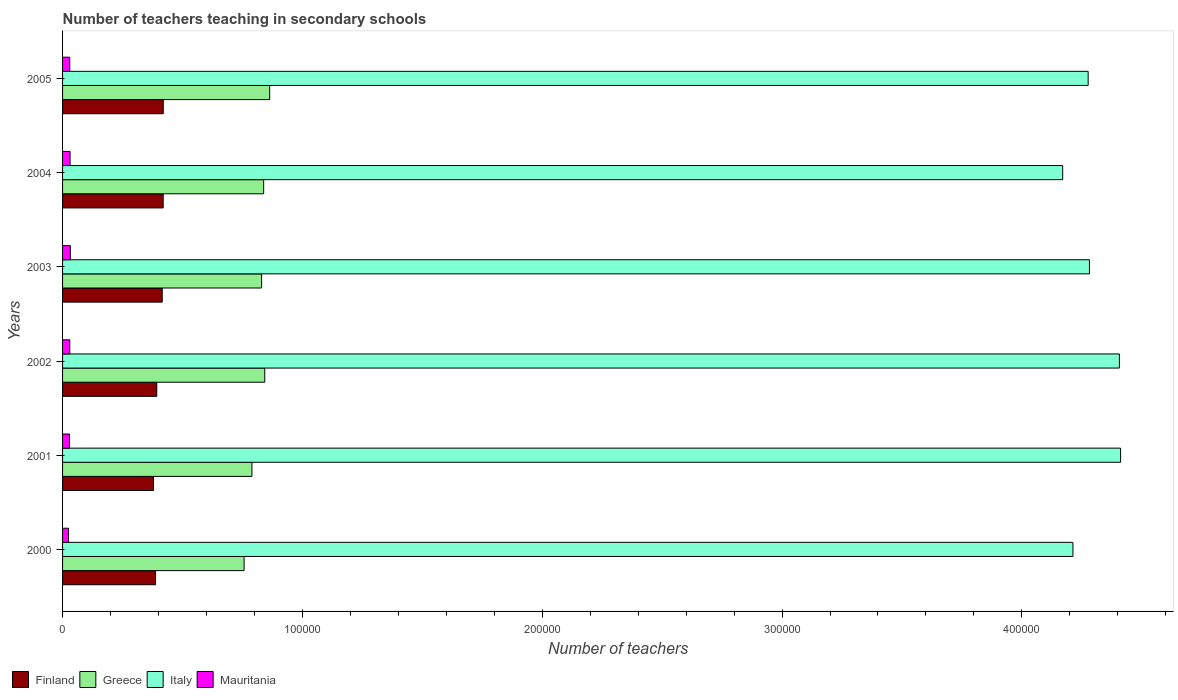How many different coloured bars are there?
Ensure brevity in your answer.  4. How many groups of bars are there?
Offer a very short reply. 6. Are the number of bars on each tick of the Y-axis equal?
Provide a short and direct response. Yes. How many bars are there on the 3rd tick from the bottom?
Make the answer very short. 4. What is the label of the 6th group of bars from the top?
Make the answer very short. 2000. What is the number of teachers teaching in secondary schools in Italy in 2001?
Give a very brief answer. 4.41e+05. Across all years, what is the maximum number of teachers teaching in secondary schools in Mauritania?
Provide a short and direct response. 3237. Across all years, what is the minimum number of teachers teaching in secondary schools in Finland?
Provide a succinct answer. 3.79e+04. In which year was the number of teachers teaching in secondary schools in Italy minimum?
Offer a very short reply. 2004. What is the total number of teachers teaching in secondary schools in Finland in the graph?
Your answer should be compact. 2.41e+05. What is the difference between the number of teachers teaching in secondary schools in Greece in 2002 and that in 2004?
Your answer should be very brief. 457. What is the difference between the number of teachers teaching in secondary schools in Mauritania in 2004 and the number of teachers teaching in secondary schools in Italy in 2002?
Give a very brief answer. -4.38e+05. What is the average number of teachers teaching in secondary schools in Italy per year?
Provide a succinct answer. 4.29e+05. In the year 2004, what is the difference between the number of teachers teaching in secondary schools in Mauritania and number of teachers teaching in secondary schools in Italy?
Make the answer very short. -4.14e+05. What is the ratio of the number of teachers teaching in secondary schools in Greece in 2000 to that in 2005?
Ensure brevity in your answer.  0.88. Is the difference between the number of teachers teaching in secondary schools in Mauritania in 2000 and 2003 greater than the difference between the number of teachers teaching in secondary schools in Italy in 2000 and 2003?
Offer a terse response. Yes. What is the difference between the highest and the second highest number of teachers teaching in secondary schools in Italy?
Keep it short and to the point. 501. What is the difference between the highest and the lowest number of teachers teaching in secondary schools in Finland?
Your answer should be very brief. 4057. Is the sum of the number of teachers teaching in secondary schools in Finland in 2004 and 2005 greater than the maximum number of teachers teaching in secondary schools in Mauritania across all years?
Your answer should be very brief. Yes. What does the 4th bar from the top in 2004 represents?
Provide a succinct answer. Finland. What does the 4th bar from the bottom in 2002 represents?
Offer a very short reply. Mauritania. How many bars are there?
Your response must be concise. 24. Are all the bars in the graph horizontal?
Make the answer very short. Yes. What is the difference between two consecutive major ticks on the X-axis?
Your response must be concise. 1.00e+05. Are the values on the major ticks of X-axis written in scientific E-notation?
Keep it short and to the point. No. Does the graph contain any zero values?
Keep it short and to the point. No. Where does the legend appear in the graph?
Ensure brevity in your answer.  Bottom left. How many legend labels are there?
Offer a terse response. 4. How are the legend labels stacked?
Give a very brief answer. Horizontal. What is the title of the graph?
Your response must be concise. Number of teachers teaching in secondary schools. What is the label or title of the X-axis?
Give a very brief answer. Number of teachers. What is the label or title of the Y-axis?
Provide a succinct answer. Years. What is the Number of teachers of Finland in 2000?
Offer a very short reply. 3.88e+04. What is the Number of teachers of Greece in 2000?
Provide a short and direct response. 7.57e+04. What is the Number of teachers of Italy in 2000?
Provide a succinct answer. 4.21e+05. What is the Number of teachers in Mauritania in 2000?
Offer a very short reply. 2492. What is the Number of teachers in Finland in 2001?
Make the answer very short. 3.79e+04. What is the Number of teachers in Greece in 2001?
Provide a succinct answer. 7.90e+04. What is the Number of teachers in Italy in 2001?
Make the answer very short. 4.41e+05. What is the Number of teachers in Mauritania in 2001?
Your answer should be very brief. 2911. What is the Number of teachers in Finland in 2002?
Offer a terse response. 3.93e+04. What is the Number of teachers of Greece in 2002?
Provide a succinct answer. 8.43e+04. What is the Number of teachers in Italy in 2002?
Ensure brevity in your answer.  4.41e+05. What is the Number of teachers of Mauritania in 2002?
Keep it short and to the point. 3000. What is the Number of teachers in Finland in 2003?
Your answer should be very brief. 4.16e+04. What is the Number of teachers in Greece in 2003?
Keep it short and to the point. 8.30e+04. What is the Number of teachers of Italy in 2003?
Keep it short and to the point. 4.28e+05. What is the Number of teachers in Mauritania in 2003?
Keep it short and to the point. 3237. What is the Number of teachers in Finland in 2004?
Provide a short and direct response. 4.20e+04. What is the Number of teachers in Greece in 2004?
Provide a short and direct response. 8.38e+04. What is the Number of teachers in Italy in 2004?
Provide a short and direct response. 4.17e+05. What is the Number of teachers in Mauritania in 2004?
Offer a terse response. 3126. What is the Number of teachers in Finland in 2005?
Keep it short and to the point. 4.20e+04. What is the Number of teachers in Greece in 2005?
Offer a terse response. 8.64e+04. What is the Number of teachers in Italy in 2005?
Make the answer very short. 4.28e+05. What is the Number of teachers of Mauritania in 2005?
Offer a very short reply. 2995. Across all years, what is the maximum Number of teachers of Finland?
Give a very brief answer. 4.20e+04. Across all years, what is the maximum Number of teachers of Greece?
Your response must be concise. 8.64e+04. Across all years, what is the maximum Number of teachers in Italy?
Your answer should be very brief. 4.41e+05. Across all years, what is the maximum Number of teachers of Mauritania?
Give a very brief answer. 3237. Across all years, what is the minimum Number of teachers in Finland?
Offer a terse response. 3.79e+04. Across all years, what is the minimum Number of teachers of Greece?
Give a very brief answer. 7.57e+04. Across all years, what is the minimum Number of teachers in Italy?
Ensure brevity in your answer.  4.17e+05. Across all years, what is the minimum Number of teachers in Mauritania?
Provide a short and direct response. 2492. What is the total Number of teachers of Finland in the graph?
Make the answer very short. 2.41e+05. What is the total Number of teachers of Greece in the graph?
Your answer should be very brief. 4.92e+05. What is the total Number of teachers in Italy in the graph?
Ensure brevity in your answer.  2.58e+06. What is the total Number of teachers of Mauritania in the graph?
Your answer should be compact. 1.78e+04. What is the difference between the Number of teachers of Finland in 2000 and that in 2001?
Your answer should be compact. 851. What is the difference between the Number of teachers of Greece in 2000 and that in 2001?
Your answer should be very brief. -3274. What is the difference between the Number of teachers of Italy in 2000 and that in 2001?
Keep it short and to the point. -1.99e+04. What is the difference between the Number of teachers in Mauritania in 2000 and that in 2001?
Provide a succinct answer. -419. What is the difference between the Number of teachers of Finland in 2000 and that in 2002?
Ensure brevity in your answer.  -500. What is the difference between the Number of teachers of Greece in 2000 and that in 2002?
Ensure brevity in your answer.  -8616. What is the difference between the Number of teachers of Italy in 2000 and that in 2002?
Provide a succinct answer. -1.94e+04. What is the difference between the Number of teachers in Mauritania in 2000 and that in 2002?
Provide a short and direct response. -508. What is the difference between the Number of teachers of Finland in 2000 and that in 2003?
Your answer should be compact. -2779. What is the difference between the Number of teachers of Greece in 2000 and that in 2003?
Ensure brevity in your answer.  -7315. What is the difference between the Number of teachers of Italy in 2000 and that in 2003?
Ensure brevity in your answer.  -6880. What is the difference between the Number of teachers of Mauritania in 2000 and that in 2003?
Keep it short and to the point. -745. What is the difference between the Number of teachers of Finland in 2000 and that in 2004?
Make the answer very short. -3177. What is the difference between the Number of teachers in Greece in 2000 and that in 2004?
Keep it short and to the point. -8159. What is the difference between the Number of teachers of Italy in 2000 and that in 2004?
Make the answer very short. 4274. What is the difference between the Number of teachers in Mauritania in 2000 and that in 2004?
Keep it short and to the point. -634. What is the difference between the Number of teachers in Finland in 2000 and that in 2005?
Give a very brief answer. -3206. What is the difference between the Number of teachers in Greece in 2000 and that in 2005?
Provide a succinct answer. -1.07e+04. What is the difference between the Number of teachers in Italy in 2000 and that in 2005?
Ensure brevity in your answer.  -6349. What is the difference between the Number of teachers in Mauritania in 2000 and that in 2005?
Keep it short and to the point. -503. What is the difference between the Number of teachers of Finland in 2001 and that in 2002?
Offer a very short reply. -1351. What is the difference between the Number of teachers in Greece in 2001 and that in 2002?
Give a very brief answer. -5342. What is the difference between the Number of teachers in Italy in 2001 and that in 2002?
Provide a short and direct response. 501. What is the difference between the Number of teachers of Mauritania in 2001 and that in 2002?
Provide a succinct answer. -89. What is the difference between the Number of teachers of Finland in 2001 and that in 2003?
Ensure brevity in your answer.  -3630. What is the difference between the Number of teachers in Greece in 2001 and that in 2003?
Offer a very short reply. -4041. What is the difference between the Number of teachers in Italy in 2001 and that in 2003?
Your response must be concise. 1.30e+04. What is the difference between the Number of teachers of Mauritania in 2001 and that in 2003?
Your response must be concise. -326. What is the difference between the Number of teachers of Finland in 2001 and that in 2004?
Give a very brief answer. -4028. What is the difference between the Number of teachers in Greece in 2001 and that in 2004?
Keep it short and to the point. -4885. What is the difference between the Number of teachers in Italy in 2001 and that in 2004?
Provide a succinct answer. 2.41e+04. What is the difference between the Number of teachers in Mauritania in 2001 and that in 2004?
Keep it short and to the point. -215. What is the difference between the Number of teachers of Finland in 2001 and that in 2005?
Your answer should be very brief. -4057. What is the difference between the Number of teachers in Greece in 2001 and that in 2005?
Your answer should be compact. -7402. What is the difference between the Number of teachers in Italy in 2001 and that in 2005?
Keep it short and to the point. 1.35e+04. What is the difference between the Number of teachers in Mauritania in 2001 and that in 2005?
Provide a short and direct response. -84. What is the difference between the Number of teachers in Finland in 2002 and that in 2003?
Offer a very short reply. -2279. What is the difference between the Number of teachers in Greece in 2002 and that in 2003?
Make the answer very short. 1301. What is the difference between the Number of teachers in Italy in 2002 and that in 2003?
Your answer should be very brief. 1.25e+04. What is the difference between the Number of teachers in Mauritania in 2002 and that in 2003?
Make the answer very short. -237. What is the difference between the Number of teachers in Finland in 2002 and that in 2004?
Keep it short and to the point. -2677. What is the difference between the Number of teachers in Greece in 2002 and that in 2004?
Your answer should be very brief. 457. What is the difference between the Number of teachers of Italy in 2002 and that in 2004?
Give a very brief answer. 2.36e+04. What is the difference between the Number of teachers in Mauritania in 2002 and that in 2004?
Give a very brief answer. -126. What is the difference between the Number of teachers of Finland in 2002 and that in 2005?
Your response must be concise. -2706. What is the difference between the Number of teachers of Greece in 2002 and that in 2005?
Keep it short and to the point. -2060. What is the difference between the Number of teachers in Italy in 2002 and that in 2005?
Make the answer very short. 1.30e+04. What is the difference between the Number of teachers of Mauritania in 2002 and that in 2005?
Your answer should be very brief. 5. What is the difference between the Number of teachers of Finland in 2003 and that in 2004?
Give a very brief answer. -398. What is the difference between the Number of teachers of Greece in 2003 and that in 2004?
Ensure brevity in your answer.  -844. What is the difference between the Number of teachers in Italy in 2003 and that in 2004?
Your answer should be very brief. 1.12e+04. What is the difference between the Number of teachers of Mauritania in 2003 and that in 2004?
Give a very brief answer. 111. What is the difference between the Number of teachers of Finland in 2003 and that in 2005?
Your answer should be compact. -427. What is the difference between the Number of teachers in Greece in 2003 and that in 2005?
Your answer should be compact. -3361. What is the difference between the Number of teachers in Italy in 2003 and that in 2005?
Ensure brevity in your answer.  531. What is the difference between the Number of teachers of Mauritania in 2003 and that in 2005?
Provide a short and direct response. 242. What is the difference between the Number of teachers of Finland in 2004 and that in 2005?
Give a very brief answer. -29. What is the difference between the Number of teachers in Greece in 2004 and that in 2005?
Make the answer very short. -2517. What is the difference between the Number of teachers of Italy in 2004 and that in 2005?
Keep it short and to the point. -1.06e+04. What is the difference between the Number of teachers of Mauritania in 2004 and that in 2005?
Provide a short and direct response. 131. What is the difference between the Number of teachers in Finland in 2000 and the Number of teachers in Greece in 2001?
Your answer should be very brief. -4.02e+04. What is the difference between the Number of teachers of Finland in 2000 and the Number of teachers of Italy in 2001?
Provide a short and direct response. -4.02e+05. What is the difference between the Number of teachers in Finland in 2000 and the Number of teachers in Mauritania in 2001?
Provide a short and direct response. 3.59e+04. What is the difference between the Number of teachers in Greece in 2000 and the Number of teachers in Italy in 2001?
Provide a succinct answer. -3.65e+05. What is the difference between the Number of teachers of Greece in 2000 and the Number of teachers of Mauritania in 2001?
Keep it short and to the point. 7.28e+04. What is the difference between the Number of teachers of Italy in 2000 and the Number of teachers of Mauritania in 2001?
Offer a terse response. 4.18e+05. What is the difference between the Number of teachers in Finland in 2000 and the Number of teachers in Greece in 2002?
Give a very brief answer. -4.55e+04. What is the difference between the Number of teachers in Finland in 2000 and the Number of teachers in Italy in 2002?
Your response must be concise. -4.02e+05. What is the difference between the Number of teachers of Finland in 2000 and the Number of teachers of Mauritania in 2002?
Your answer should be very brief. 3.58e+04. What is the difference between the Number of teachers in Greece in 2000 and the Number of teachers in Italy in 2002?
Provide a short and direct response. -3.65e+05. What is the difference between the Number of teachers in Greece in 2000 and the Number of teachers in Mauritania in 2002?
Provide a short and direct response. 7.27e+04. What is the difference between the Number of teachers in Italy in 2000 and the Number of teachers in Mauritania in 2002?
Provide a succinct answer. 4.18e+05. What is the difference between the Number of teachers in Finland in 2000 and the Number of teachers in Greece in 2003?
Give a very brief answer. -4.42e+04. What is the difference between the Number of teachers in Finland in 2000 and the Number of teachers in Italy in 2003?
Your answer should be very brief. -3.89e+05. What is the difference between the Number of teachers of Finland in 2000 and the Number of teachers of Mauritania in 2003?
Give a very brief answer. 3.55e+04. What is the difference between the Number of teachers in Greece in 2000 and the Number of teachers in Italy in 2003?
Offer a terse response. -3.52e+05. What is the difference between the Number of teachers of Greece in 2000 and the Number of teachers of Mauritania in 2003?
Offer a terse response. 7.25e+04. What is the difference between the Number of teachers of Italy in 2000 and the Number of teachers of Mauritania in 2003?
Provide a short and direct response. 4.18e+05. What is the difference between the Number of teachers in Finland in 2000 and the Number of teachers in Greece in 2004?
Provide a succinct answer. -4.51e+04. What is the difference between the Number of teachers of Finland in 2000 and the Number of teachers of Italy in 2004?
Ensure brevity in your answer.  -3.78e+05. What is the difference between the Number of teachers in Finland in 2000 and the Number of teachers in Mauritania in 2004?
Your answer should be very brief. 3.56e+04. What is the difference between the Number of teachers in Greece in 2000 and the Number of teachers in Italy in 2004?
Offer a very short reply. -3.41e+05. What is the difference between the Number of teachers of Greece in 2000 and the Number of teachers of Mauritania in 2004?
Offer a terse response. 7.26e+04. What is the difference between the Number of teachers of Italy in 2000 and the Number of teachers of Mauritania in 2004?
Provide a succinct answer. 4.18e+05. What is the difference between the Number of teachers in Finland in 2000 and the Number of teachers in Greece in 2005?
Your response must be concise. -4.76e+04. What is the difference between the Number of teachers of Finland in 2000 and the Number of teachers of Italy in 2005?
Your answer should be very brief. -3.89e+05. What is the difference between the Number of teachers in Finland in 2000 and the Number of teachers in Mauritania in 2005?
Provide a short and direct response. 3.58e+04. What is the difference between the Number of teachers of Greece in 2000 and the Number of teachers of Italy in 2005?
Offer a terse response. -3.52e+05. What is the difference between the Number of teachers in Greece in 2000 and the Number of teachers in Mauritania in 2005?
Provide a succinct answer. 7.27e+04. What is the difference between the Number of teachers of Italy in 2000 and the Number of teachers of Mauritania in 2005?
Your answer should be compact. 4.18e+05. What is the difference between the Number of teachers of Finland in 2001 and the Number of teachers of Greece in 2002?
Your response must be concise. -4.64e+04. What is the difference between the Number of teachers of Finland in 2001 and the Number of teachers of Italy in 2002?
Your response must be concise. -4.03e+05. What is the difference between the Number of teachers in Finland in 2001 and the Number of teachers in Mauritania in 2002?
Give a very brief answer. 3.49e+04. What is the difference between the Number of teachers in Greece in 2001 and the Number of teachers in Italy in 2002?
Offer a terse response. -3.62e+05. What is the difference between the Number of teachers of Greece in 2001 and the Number of teachers of Mauritania in 2002?
Provide a short and direct response. 7.60e+04. What is the difference between the Number of teachers of Italy in 2001 and the Number of teachers of Mauritania in 2002?
Offer a very short reply. 4.38e+05. What is the difference between the Number of teachers of Finland in 2001 and the Number of teachers of Greece in 2003?
Provide a short and direct response. -4.51e+04. What is the difference between the Number of teachers in Finland in 2001 and the Number of teachers in Italy in 2003?
Provide a succinct answer. -3.90e+05. What is the difference between the Number of teachers of Finland in 2001 and the Number of teachers of Mauritania in 2003?
Offer a terse response. 3.47e+04. What is the difference between the Number of teachers of Greece in 2001 and the Number of teachers of Italy in 2003?
Ensure brevity in your answer.  -3.49e+05. What is the difference between the Number of teachers of Greece in 2001 and the Number of teachers of Mauritania in 2003?
Keep it short and to the point. 7.57e+04. What is the difference between the Number of teachers of Italy in 2001 and the Number of teachers of Mauritania in 2003?
Keep it short and to the point. 4.38e+05. What is the difference between the Number of teachers in Finland in 2001 and the Number of teachers in Greece in 2004?
Your response must be concise. -4.59e+04. What is the difference between the Number of teachers in Finland in 2001 and the Number of teachers in Italy in 2004?
Offer a terse response. -3.79e+05. What is the difference between the Number of teachers of Finland in 2001 and the Number of teachers of Mauritania in 2004?
Your answer should be very brief. 3.48e+04. What is the difference between the Number of teachers in Greece in 2001 and the Number of teachers in Italy in 2004?
Offer a terse response. -3.38e+05. What is the difference between the Number of teachers in Greece in 2001 and the Number of teachers in Mauritania in 2004?
Your answer should be very brief. 7.58e+04. What is the difference between the Number of teachers in Italy in 2001 and the Number of teachers in Mauritania in 2004?
Provide a succinct answer. 4.38e+05. What is the difference between the Number of teachers of Finland in 2001 and the Number of teachers of Greece in 2005?
Make the answer very short. -4.84e+04. What is the difference between the Number of teachers in Finland in 2001 and the Number of teachers in Italy in 2005?
Offer a very short reply. -3.90e+05. What is the difference between the Number of teachers in Finland in 2001 and the Number of teachers in Mauritania in 2005?
Offer a very short reply. 3.49e+04. What is the difference between the Number of teachers of Greece in 2001 and the Number of teachers of Italy in 2005?
Your answer should be compact. -3.49e+05. What is the difference between the Number of teachers of Greece in 2001 and the Number of teachers of Mauritania in 2005?
Make the answer very short. 7.60e+04. What is the difference between the Number of teachers in Italy in 2001 and the Number of teachers in Mauritania in 2005?
Your answer should be very brief. 4.38e+05. What is the difference between the Number of teachers of Finland in 2002 and the Number of teachers of Greece in 2003?
Offer a very short reply. -4.37e+04. What is the difference between the Number of teachers in Finland in 2002 and the Number of teachers in Italy in 2003?
Ensure brevity in your answer.  -3.89e+05. What is the difference between the Number of teachers of Finland in 2002 and the Number of teachers of Mauritania in 2003?
Provide a short and direct response. 3.60e+04. What is the difference between the Number of teachers of Greece in 2002 and the Number of teachers of Italy in 2003?
Give a very brief answer. -3.44e+05. What is the difference between the Number of teachers in Greece in 2002 and the Number of teachers in Mauritania in 2003?
Keep it short and to the point. 8.11e+04. What is the difference between the Number of teachers in Italy in 2002 and the Number of teachers in Mauritania in 2003?
Your response must be concise. 4.37e+05. What is the difference between the Number of teachers in Finland in 2002 and the Number of teachers in Greece in 2004?
Provide a succinct answer. -4.46e+04. What is the difference between the Number of teachers in Finland in 2002 and the Number of teachers in Italy in 2004?
Make the answer very short. -3.78e+05. What is the difference between the Number of teachers in Finland in 2002 and the Number of teachers in Mauritania in 2004?
Make the answer very short. 3.62e+04. What is the difference between the Number of teachers of Greece in 2002 and the Number of teachers of Italy in 2004?
Give a very brief answer. -3.33e+05. What is the difference between the Number of teachers in Greece in 2002 and the Number of teachers in Mauritania in 2004?
Your answer should be very brief. 8.12e+04. What is the difference between the Number of teachers of Italy in 2002 and the Number of teachers of Mauritania in 2004?
Your response must be concise. 4.38e+05. What is the difference between the Number of teachers in Finland in 2002 and the Number of teachers in Greece in 2005?
Provide a succinct answer. -4.71e+04. What is the difference between the Number of teachers in Finland in 2002 and the Number of teachers in Italy in 2005?
Provide a succinct answer. -3.88e+05. What is the difference between the Number of teachers of Finland in 2002 and the Number of teachers of Mauritania in 2005?
Your response must be concise. 3.63e+04. What is the difference between the Number of teachers of Greece in 2002 and the Number of teachers of Italy in 2005?
Offer a terse response. -3.43e+05. What is the difference between the Number of teachers of Greece in 2002 and the Number of teachers of Mauritania in 2005?
Keep it short and to the point. 8.13e+04. What is the difference between the Number of teachers in Italy in 2002 and the Number of teachers in Mauritania in 2005?
Ensure brevity in your answer.  4.38e+05. What is the difference between the Number of teachers in Finland in 2003 and the Number of teachers in Greece in 2004?
Your answer should be very brief. -4.23e+04. What is the difference between the Number of teachers in Finland in 2003 and the Number of teachers in Italy in 2004?
Provide a short and direct response. -3.75e+05. What is the difference between the Number of teachers in Finland in 2003 and the Number of teachers in Mauritania in 2004?
Offer a very short reply. 3.84e+04. What is the difference between the Number of teachers in Greece in 2003 and the Number of teachers in Italy in 2004?
Make the answer very short. -3.34e+05. What is the difference between the Number of teachers of Greece in 2003 and the Number of teachers of Mauritania in 2004?
Offer a terse response. 7.99e+04. What is the difference between the Number of teachers of Italy in 2003 and the Number of teachers of Mauritania in 2004?
Offer a very short reply. 4.25e+05. What is the difference between the Number of teachers in Finland in 2003 and the Number of teachers in Greece in 2005?
Provide a short and direct response. -4.48e+04. What is the difference between the Number of teachers of Finland in 2003 and the Number of teachers of Italy in 2005?
Your response must be concise. -3.86e+05. What is the difference between the Number of teachers of Finland in 2003 and the Number of teachers of Mauritania in 2005?
Offer a very short reply. 3.86e+04. What is the difference between the Number of teachers of Greece in 2003 and the Number of teachers of Italy in 2005?
Give a very brief answer. -3.45e+05. What is the difference between the Number of teachers in Greece in 2003 and the Number of teachers in Mauritania in 2005?
Offer a very short reply. 8.00e+04. What is the difference between the Number of teachers in Italy in 2003 and the Number of teachers in Mauritania in 2005?
Keep it short and to the point. 4.25e+05. What is the difference between the Number of teachers of Finland in 2004 and the Number of teachers of Greece in 2005?
Offer a terse response. -4.44e+04. What is the difference between the Number of teachers in Finland in 2004 and the Number of teachers in Italy in 2005?
Offer a terse response. -3.86e+05. What is the difference between the Number of teachers of Finland in 2004 and the Number of teachers of Mauritania in 2005?
Ensure brevity in your answer.  3.90e+04. What is the difference between the Number of teachers in Greece in 2004 and the Number of teachers in Italy in 2005?
Offer a very short reply. -3.44e+05. What is the difference between the Number of teachers in Greece in 2004 and the Number of teachers in Mauritania in 2005?
Ensure brevity in your answer.  8.09e+04. What is the difference between the Number of teachers in Italy in 2004 and the Number of teachers in Mauritania in 2005?
Offer a very short reply. 4.14e+05. What is the average Number of teachers of Finland per year?
Your response must be concise. 4.02e+04. What is the average Number of teachers of Greece per year?
Keep it short and to the point. 8.20e+04. What is the average Number of teachers of Italy per year?
Offer a terse response. 4.29e+05. What is the average Number of teachers of Mauritania per year?
Your answer should be compact. 2960.17. In the year 2000, what is the difference between the Number of teachers in Finland and Number of teachers in Greece?
Provide a short and direct response. -3.69e+04. In the year 2000, what is the difference between the Number of teachers in Finland and Number of teachers in Italy?
Your answer should be very brief. -3.83e+05. In the year 2000, what is the difference between the Number of teachers in Finland and Number of teachers in Mauritania?
Offer a very short reply. 3.63e+04. In the year 2000, what is the difference between the Number of teachers of Greece and Number of teachers of Italy?
Your response must be concise. -3.46e+05. In the year 2000, what is the difference between the Number of teachers of Greece and Number of teachers of Mauritania?
Provide a succinct answer. 7.32e+04. In the year 2000, what is the difference between the Number of teachers of Italy and Number of teachers of Mauritania?
Provide a short and direct response. 4.19e+05. In the year 2001, what is the difference between the Number of teachers of Finland and Number of teachers of Greece?
Ensure brevity in your answer.  -4.10e+04. In the year 2001, what is the difference between the Number of teachers in Finland and Number of teachers in Italy?
Make the answer very short. -4.03e+05. In the year 2001, what is the difference between the Number of teachers of Finland and Number of teachers of Mauritania?
Offer a very short reply. 3.50e+04. In the year 2001, what is the difference between the Number of teachers of Greece and Number of teachers of Italy?
Make the answer very short. -3.62e+05. In the year 2001, what is the difference between the Number of teachers in Greece and Number of teachers in Mauritania?
Provide a succinct answer. 7.61e+04. In the year 2001, what is the difference between the Number of teachers of Italy and Number of teachers of Mauritania?
Your answer should be very brief. 4.38e+05. In the year 2002, what is the difference between the Number of teachers in Finland and Number of teachers in Greece?
Ensure brevity in your answer.  -4.50e+04. In the year 2002, what is the difference between the Number of teachers of Finland and Number of teachers of Italy?
Give a very brief answer. -4.01e+05. In the year 2002, what is the difference between the Number of teachers of Finland and Number of teachers of Mauritania?
Ensure brevity in your answer.  3.63e+04. In the year 2002, what is the difference between the Number of teachers of Greece and Number of teachers of Italy?
Keep it short and to the point. -3.56e+05. In the year 2002, what is the difference between the Number of teachers of Greece and Number of teachers of Mauritania?
Your answer should be very brief. 8.13e+04. In the year 2002, what is the difference between the Number of teachers of Italy and Number of teachers of Mauritania?
Your answer should be compact. 4.38e+05. In the year 2003, what is the difference between the Number of teachers in Finland and Number of teachers in Greece?
Provide a succinct answer. -4.14e+04. In the year 2003, what is the difference between the Number of teachers of Finland and Number of teachers of Italy?
Keep it short and to the point. -3.87e+05. In the year 2003, what is the difference between the Number of teachers in Finland and Number of teachers in Mauritania?
Your answer should be very brief. 3.83e+04. In the year 2003, what is the difference between the Number of teachers in Greece and Number of teachers in Italy?
Keep it short and to the point. -3.45e+05. In the year 2003, what is the difference between the Number of teachers in Greece and Number of teachers in Mauritania?
Make the answer very short. 7.98e+04. In the year 2003, what is the difference between the Number of teachers of Italy and Number of teachers of Mauritania?
Make the answer very short. 4.25e+05. In the year 2004, what is the difference between the Number of teachers in Finland and Number of teachers in Greece?
Your answer should be compact. -4.19e+04. In the year 2004, what is the difference between the Number of teachers in Finland and Number of teachers in Italy?
Keep it short and to the point. -3.75e+05. In the year 2004, what is the difference between the Number of teachers of Finland and Number of teachers of Mauritania?
Keep it short and to the point. 3.88e+04. In the year 2004, what is the difference between the Number of teachers in Greece and Number of teachers in Italy?
Keep it short and to the point. -3.33e+05. In the year 2004, what is the difference between the Number of teachers of Greece and Number of teachers of Mauritania?
Keep it short and to the point. 8.07e+04. In the year 2004, what is the difference between the Number of teachers of Italy and Number of teachers of Mauritania?
Offer a terse response. 4.14e+05. In the year 2005, what is the difference between the Number of teachers of Finland and Number of teachers of Greece?
Keep it short and to the point. -4.44e+04. In the year 2005, what is the difference between the Number of teachers in Finland and Number of teachers in Italy?
Make the answer very short. -3.86e+05. In the year 2005, what is the difference between the Number of teachers of Finland and Number of teachers of Mauritania?
Provide a succinct answer. 3.90e+04. In the year 2005, what is the difference between the Number of teachers in Greece and Number of teachers in Italy?
Your response must be concise. -3.41e+05. In the year 2005, what is the difference between the Number of teachers in Greece and Number of teachers in Mauritania?
Ensure brevity in your answer.  8.34e+04. In the year 2005, what is the difference between the Number of teachers of Italy and Number of teachers of Mauritania?
Offer a very short reply. 4.25e+05. What is the ratio of the Number of teachers of Finland in 2000 to that in 2001?
Give a very brief answer. 1.02. What is the ratio of the Number of teachers in Greece in 2000 to that in 2001?
Make the answer very short. 0.96. What is the ratio of the Number of teachers of Italy in 2000 to that in 2001?
Provide a succinct answer. 0.95. What is the ratio of the Number of teachers of Mauritania in 2000 to that in 2001?
Keep it short and to the point. 0.86. What is the ratio of the Number of teachers of Finland in 2000 to that in 2002?
Offer a terse response. 0.99. What is the ratio of the Number of teachers in Greece in 2000 to that in 2002?
Offer a very short reply. 0.9. What is the ratio of the Number of teachers in Italy in 2000 to that in 2002?
Ensure brevity in your answer.  0.96. What is the ratio of the Number of teachers in Mauritania in 2000 to that in 2002?
Your answer should be very brief. 0.83. What is the ratio of the Number of teachers of Finland in 2000 to that in 2003?
Keep it short and to the point. 0.93. What is the ratio of the Number of teachers in Greece in 2000 to that in 2003?
Provide a short and direct response. 0.91. What is the ratio of the Number of teachers of Italy in 2000 to that in 2003?
Your answer should be compact. 0.98. What is the ratio of the Number of teachers in Mauritania in 2000 to that in 2003?
Provide a succinct answer. 0.77. What is the ratio of the Number of teachers in Finland in 2000 to that in 2004?
Give a very brief answer. 0.92. What is the ratio of the Number of teachers of Greece in 2000 to that in 2004?
Your answer should be very brief. 0.9. What is the ratio of the Number of teachers in Italy in 2000 to that in 2004?
Your answer should be compact. 1.01. What is the ratio of the Number of teachers in Mauritania in 2000 to that in 2004?
Provide a succinct answer. 0.8. What is the ratio of the Number of teachers in Finland in 2000 to that in 2005?
Your answer should be very brief. 0.92. What is the ratio of the Number of teachers of Greece in 2000 to that in 2005?
Your answer should be compact. 0.88. What is the ratio of the Number of teachers of Italy in 2000 to that in 2005?
Ensure brevity in your answer.  0.99. What is the ratio of the Number of teachers of Mauritania in 2000 to that in 2005?
Your response must be concise. 0.83. What is the ratio of the Number of teachers of Finland in 2001 to that in 2002?
Provide a short and direct response. 0.97. What is the ratio of the Number of teachers in Greece in 2001 to that in 2002?
Your answer should be compact. 0.94. What is the ratio of the Number of teachers in Mauritania in 2001 to that in 2002?
Give a very brief answer. 0.97. What is the ratio of the Number of teachers of Finland in 2001 to that in 2003?
Keep it short and to the point. 0.91. What is the ratio of the Number of teachers of Greece in 2001 to that in 2003?
Your response must be concise. 0.95. What is the ratio of the Number of teachers of Italy in 2001 to that in 2003?
Give a very brief answer. 1.03. What is the ratio of the Number of teachers of Mauritania in 2001 to that in 2003?
Give a very brief answer. 0.9. What is the ratio of the Number of teachers in Finland in 2001 to that in 2004?
Keep it short and to the point. 0.9. What is the ratio of the Number of teachers of Greece in 2001 to that in 2004?
Offer a terse response. 0.94. What is the ratio of the Number of teachers in Italy in 2001 to that in 2004?
Your answer should be compact. 1.06. What is the ratio of the Number of teachers of Mauritania in 2001 to that in 2004?
Provide a short and direct response. 0.93. What is the ratio of the Number of teachers of Finland in 2001 to that in 2005?
Provide a succinct answer. 0.9. What is the ratio of the Number of teachers of Greece in 2001 to that in 2005?
Keep it short and to the point. 0.91. What is the ratio of the Number of teachers of Italy in 2001 to that in 2005?
Keep it short and to the point. 1.03. What is the ratio of the Number of teachers of Finland in 2002 to that in 2003?
Keep it short and to the point. 0.95. What is the ratio of the Number of teachers in Greece in 2002 to that in 2003?
Offer a terse response. 1.02. What is the ratio of the Number of teachers in Italy in 2002 to that in 2003?
Your answer should be compact. 1.03. What is the ratio of the Number of teachers of Mauritania in 2002 to that in 2003?
Offer a very short reply. 0.93. What is the ratio of the Number of teachers in Finland in 2002 to that in 2004?
Provide a succinct answer. 0.94. What is the ratio of the Number of teachers in Italy in 2002 to that in 2004?
Give a very brief answer. 1.06. What is the ratio of the Number of teachers in Mauritania in 2002 to that in 2004?
Ensure brevity in your answer.  0.96. What is the ratio of the Number of teachers of Finland in 2002 to that in 2005?
Your answer should be compact. 0.94. What is the ratio of the Number of teachers in Greece in 2002 to that in 2005?
Offer a terse response. 0.98. What is the ratio of the Number of teachers of Italy in 2002 to that in 2005?
Offer a very short reply. 1.03. What is the ratio of the Number of teachers in Greece in 2003 to that in 2004?
Your answer should be compact. 0.99. What is the ratio of the Number of teachers of Italy in 2003 to that in 2004?
Your answer should be very brief. 1.03. What is the ratio of the Number of teachers of Mauritania in 2003 to that in 2004?
Give a very brief answer. 1.04. What is the ratio of the Number of teachers in Finland in 2003 to that in 2005?
Offer a terse response. 0.99. What is the ratio of the Number of teachers of Greece in 2003 to that in 2005?
Give a very brief answer. 0.96. What is the ratio of the Number of teachers in Mauritania in 2003 to that in 2005?
Ensure brevity in your answer.  1.08. What is the ratio of the Number of teachers of Finland in 2004 to that in 2005?
Provide a succinct answer. 1. What is the ratio of the Number of teachers of Greece in 2004 to that in 2005?
Ensure brevity in your answer.  0.97. What is the ratio of the Number of teachers in Italy in 2004 to that in 2005?
Your answer should be compact. 0.98. What is the ratio of the Number of teachers of Mauritania in 2004 to that in 2005?
Your response must be concise. 1.04. What is the difference between the highest and the second highest Number of teachers of Finland?
Make the answer very short. 29. What is the difference between the highest and the second highest Number of teachers of Greece?
Give a very brief answer. 2060. What is the difference between the highest and the second highest Number of teachers in Italy?
Give a very brief answer. 501. What is the difference between the highest and the second highest Number of teachers in Mauritania?
Give a very brief answer. 111. What is the difference between the highest and the lowest Number of teachers in Finland?
Keep it short and to the point. 4057. What is the difference between the highest and the lowest Number of teachers in Greece?
Ensure brevity in your answer.  1.07e+04. What is the difference between the highest and the lowest Number of teachers of Italy?
Your answer should be very brief. 2.41e+04. What is the difference between the highest and the lowest Number of teachers of Mauritania?
Ensure brevity in your answer.  745. 